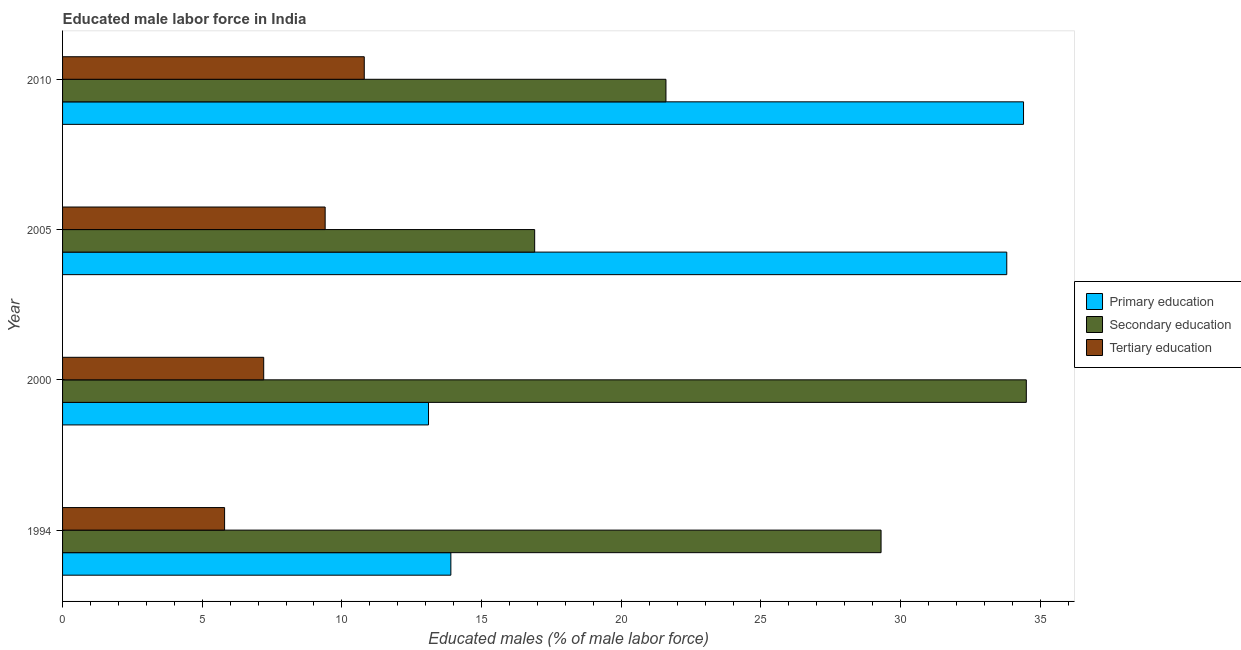How many different coloured bars are there?
Provide a succinct answer. 3. Are the number of bars per tick equal to the number of legend labels?
Provide a succinct answer. Yes. How many bars are there on the 3rd tick from the bottom?
Offer a terse response. 3. What is the label of the 3rd group of bars from the top?
Offer a terse response. 2000. What is the percentage of male labor force who received primary education in 2005?
Give a very brief answer. 33.8. Across all years, what is the maximum percentage of male labor force who received tertiary education?
Make the answer very short. 10.8. Across all years, what is the minimum percentage of male labor force who received primary education?
Your answer should be very brief. 13.1. In which year was the percentage of male labor force who received tertiary education maximum?
Provide a short and direct response. 2010. What is the total percentage of male labor force who received tertiary education in the graph?
Provide a succinct answer. 33.2. What is the difference between the percentage of male labor force who received secondary education in 2005 and that in 2010?
Provide a short and direct response. -4.7. What is the difference between the percentage of male labor force who received tertiary education in 2010 and the percentage of male labor force who received primary education in 2000?
Your answer should be very brief. -2.3. What is the average percentage of male labor force who received primary education per year?
Offer a very short reply. 23.8. In the year 1994, what is the difference between the percentage of male labor force who received secondary education and percentage of male labor force who received tertiary education?
Ensure brevity in your answer.  23.5. In how many years, is the percentage of male labor force who received primary education greater than 35 %?
Provide a succinct answer. 0. What is the ratio of the percentage of male labor force who received secondary education in 2000 to that in 2010?
Make the answer very short. 1.6. Is the percentage of male labor force who received secondary education in 2000 less than that in 2010?
Offer a terse response. No. Is the difference between the percentage of male labor force who received secondary education in 2000 and 2010 greater than the difference between the percentage of male labor force who received primary education in 2000 and 2010?
Offer a terse response. Yes. What is the difference between the highest and the second highest percentage of male labor force who received primary education?
Provide a short and direct response. 0.6. What is the difference between the highest and the lowest percentage of male labor force who received primary education?
Keep it short and to the point. 21.3. In how many years, is the percentage of male labor force who received tertiary education greater than the average percentage of male labor force who received tertiary education taken over all years?
Make the answer very short. 2. How many bars are there?
Offer a very short reply. 12. Are all the bars in the graph horizontal?
Offer a terse response. Yes. What is the difference between two consecutive major ticks on the X-axis?
Offer a terse response. 5. How are the legend labels stacked?
Provide a succinct answer. Vertical. What is the title of the graph?
Your answer should be very brief. Educated male labor force in India. What is the label or title of the X-axis?
Offer a very short reply. Educated males (% of male labor force). What is the Educated males (% of male labor force) in Primary education in 1994?
Offer a terse response. 13.9. What is the Educated males (% of male labor force) of Secondary education in 1994?
Provide a succinct answer. 29.3. What is the Educated males (% of male labor force) in Tertiary education in 1994?
Make the answer very short. 5.8. What is the Educated males (% of male labor force) of Primary education in 2000?
Give a very brief answer. 13.1. What is the Educated males (% of male labor force) in Secondary education in 2000?
Make the answer very short. 34.5. What is the Educated males (% of male labor force) of Tertiary education in 2000?
Make the answer very short. 7.2. What is the Educated males (% of male labor force) in Primary education in 2005?
Provide a short and direct response. 33.8. What is the Educated males (% of male labor force) in Secondary education in 2005?
Provide a succinct answer. 16.9. What is the Educated males (% of male labor force) in Tertiary education in 2005?
Give a very brief answer. 9.4. What is the Educated males (% of male labor force) in Primary education in 2010?
Your response must be concise. 34.4. What is the Educated males (% of male labor force) in Secondary education in 2010?
Offer a terse response. 21.6. What is the Educated males (% of male labor force) in Tertiary education in 2010?
Offer a terse response. 10.8. Across all years, what is the maximum Educated males (% of male labor force) in Primary education?
Provide a short and direct response. 34.4. Across all years, what is the maximum Educated males (% of male labor force) in Secondary education?
Offer a terse response. 34.5. Across all years, what is the maximum Educated males (% of male labor force) in Tertiary education?
Your answer should be very brief. 10.8. Across all years, what is the minimum Educated males (% of male labor force) in Primary education?
Provide a succinct answer. 13.1. Across all years, what is the minimum Educated males (% of male labor force) in Secondary education?
Your answer should be compact. 16.9. Across all years, what is the minimum Educated males (% of male labor force) of Tertiary education?
Your answer should be very brief. 5.8. What is the total Educated males (% of male labor force) in Primary education in the graph?
Give a very brief answer. 95.2. What is the total Educated males (% of male labor force) of Secondary education in the graph?
Provide a succinct answer. 102.3. What is the total Educated males (% of male labor force) in Tertiary education in the graph?
Your answer should be compact. 33.2. What is the difference between the Educated males (% of male labor force) in Tertiary education in 1994 and that in 2000?
Provide a short and direct response. -1.4. What is the difference between the Educated males (% of male labor force) in Primary education in 1994 and that in 2005?
Your answer should be compact. -19.9. What is the difference between the Educated males (% of male labor force) of Secondary education in 1994 and that in 2005?
Offer a very short reply. 12.4. What is the difference between the Educated males (% of male labor force) in Primary education in 1994 and that in 2010?
Ensure brevity in your answer.  -20.5. What is the difference between the Educated males (% of male labor force) in Primary education in 2000 and that in 2005?
Give a very brief answer. -20.7. What is the difference between the Educated males (% of male labor force) of Tertiary education in 2000 and that in 2005?
Your response must be concise. -2.2. What is the difference between the Educated males (% of male labor force) of Primary education in 2000 and that in 2010?
Your answer should be very brief. -21.3. What is the difference between the Educated males (% of male labor force) of Primary education in 2005 and that in 2010?
Provide a succinct answer. -0.6. What is the difference between the Educated males (% of male labor force) of Tertiary education in 2005 and that in 2010?
Your response must be concise. -1.4. What is the difference between the Educated males (% of male labor force) in Primary education in 1994 and the Educated males (% of male labor force) in Secondary education in 2000?
Your answer should be compact. -20.6. What is the difference between the Educated males (% of male labor force) of Secondary education in 1994 and the Educated males (% of male labor force) of Tertiary education in 2000?
Ensure brevity in your answer.  22.1. What is the difference between the Educated males (% of male labor force) in Primary education in 1994 and the Educated males (% of male labor force) in Tertiary education in 2005?
Offer a very short reply. 4.5. What is the difference between the Educated males (% of male labor force) of Primary education in 1994 and the Educated males (% of male labor force) of Secondary education in 2010?
Ensure brevity in your answer.  -7.7. What is the difference between the Educated males (% of male labor force) of Primary education in 1994 and the Educated males (% of male labor force) of Tertiary education in 2010?
Offer a terse response. 3.1. What is the difference between the Educated males (% of male labor force) of Secondary education in 1994 and the Educated males (% of male labor force) of Tertiary education in 2010?
Your response must be concise. 18.5. What is the difference between the Educated males (% of male labor force) in Primary education in 2000 and the Educated males (% of male labor force) in Tertiary education in 2005?
Provide a succinct answer. 3.7. What is the difference between the Educated males (% of male labor force) in Secondary education in 2000 and the Educated males (% of male labor force) in Tertiary education in 2005?
Offer a terse response. 25.1. What is the difference between the Educated males (% of male labor force) in Primary education in 2000 and the Educated males (% of male labor force) in Secondary education in 2010?
Offer a terse response. -8.5. What is the difference between the Educated males (% of male labor force) in Secondary education in 2000 and the Educated males (% of male labor force) in Tertiary education in 2010?
Your answer should be very brief. 23.7. What is the difference between the Educated males (% of male labor force) in Primary education in 2005 and the Educated males (% of male labor force) in Secondary education in 2010?
Keep it short and to the point. 12.2. What is the average Educated males (% of male labor force) of Primary education per year?
Give a very brief answer. 23.8. What is the average Educated males (% of male labor force) in Secondary education per year?
Your response must be concise. 25.57. What is the average Educated males (% of male labor force) of Tertiary education per year?
Your answer should be compact. 8.3. In the year 1994, what is the difference between the Educated males (% of male labor force) in Primary education and Educated males (% of male labor force) in Secondary education?
Your response must be concise. -15.4. In the year 1994, what is the difference between the Educated males (% of male labor force) of Secondary education and Educated males (% of male labor force) of Tertiary education?
Make the answer very short. 23.5. In the year 2000, what is the difference between the Educated males (% of male labor force) in Primary education and Educated males (% of male labor force) in Secondary education?
Keep it short and to the point. -21.4. In the year 2000, what is the difference between the Educated males (% of male labor force) in Primary education and Educated males (% of male labor force) in Tertiary education?
Your answer should be compact. 5.9. In the year 2000, what is the difference between the Educated males (% of male labor force) in Secondary education and Educated males (% of male labor force) in Tertiary education?
Provide a succinct answer. 27.3. In the year 2005, what is the difference between the Educated males (% of male labor force) of Primary education and Educated males (% of male labor force) of Tertiary education?
Your answer should be compact. 24.4. In the year 2005, what is the difference between the Educated males (% of male labor force) in Secondary education and Educated males (% of male labor force) in Tertiary education?
Keep it short and to the point. 7.5. In the year 2010, what is the difference between the Educated males (% of male labor force) of Primary education and Educated males (% of male labor force) of Secondary education?
Your answer should be very brief. 12.8. In the year 2010, what is the difference between the Educated males (% of male labor force) of Primary education and Educated males (% of male labor force) of Tertiary education?
Your answer should be compact. 23.6. In the year 2010, what is the difference between the Educated males (% of male labor force) in Secondary education and Educated males (% of male labor force) in Tertiary education?
Keep it short and to the point. 10.8. What is the ratio of the Educated males (% of male labor force) in Primary education in 1994 to that in 2000?
Offer a very short reply. 1.06. What is the ratio of the Educated males (% of male labor force) of Secondary education in 1994 to that in 2000?
Provide a succinct answer. 0.85. What is the ratio of the Educated males (% of male labor force) in Tertiary education in 1994 to that in 2000?
Make the answer very short. 0.81. What is the ratio of the Educated males (% of male labor force) of Primary education in 1994 to that in 2005?
Give a very brief answer. 0.41. What is the ratio of the Educated males (% of male labor force) of Secondary education in 1994 to that in 2005?
Your response must be concise. 1.73. What is the ratio of the Educated males (% of male labor force) in Tertiary education in 1994 to that in 2005?
Offer a very short reply. 0.62. What is the ratio of the Educated males (% of male labor force) in Primary education in 1994 to that in 2010?
Keep it short and to the point. 0.4. What is the ratio of the Educated males (% of male labor force) in Secondary education in 1994 to that in 2010?
Ensure brevity in your answer.  1.36. What is the ratio of the Educated males (% of male labor force) of Tertiary education in 1994 to that in 2010?
Provide a short and direct response. 0.54. What is the ratio of the Educated males (% of male labor force) in Primary education in 2000 to that in 2005?
Ensure brevity in your answer.  0.39. What is the ratio of the Educated males (% of male labor force) of Secondary education in 2000 to that in 2005?
Your answer should be very brief. 2.04. What is the ratio of the Educated males (% of male labor force) in Tertiary education in 2000 to that in 2005?
Provide a succinct answer. 0.77. What is the ratio of the Educated males (% of male labor force) of Primary education in 2000 to that in 2010?
Your answer should be very brief. 0.38. What is the ratio of the Educated males (% of male labor force) in Secondary education in 2000 to that in 2010?
Your answer should be very brief. 1.6. What is the ratio of the Educated males (% of male labor force) in Tertiary education in 2000 to that in 2010?
Provide a succinct answer. 0.67. What is the ratio of the Educated males (% of male labor force) of Primary education in 2005 to that in 2010?
Offer a very short reply. 0.98. What is the ratio of the Educated males (% of male labor force) in Secondary education in 2005 to that in 2010?
Your response must be concise. 0.78. What is the ratio of the Educated males (% of male labor force) of Tertiary education in 2005 to that in 2010?
Ensure brevity in your answer.  0.87. What is the difference between the highest and the second highest Educated males (% of male labor force) in Tertiary education?
Make the answer very short. 1.4. What is the difference between the highest and the lowest Educated males (% of male labor force) in Primary education?
Make the answer very short. 21.3. What is the difference between the highest and the lowest Educated males (% of male labor force) of Tertiary education?
Offer a very short reply. 5. 